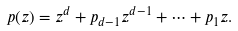<formula> <loc_0><loc_0><loc_500><loc_500>p ( z ) = z ^ { d } + p _ { d - 1 } z ^ { d - 1 } + \cdots + p _ { 1 } z .</formula> 